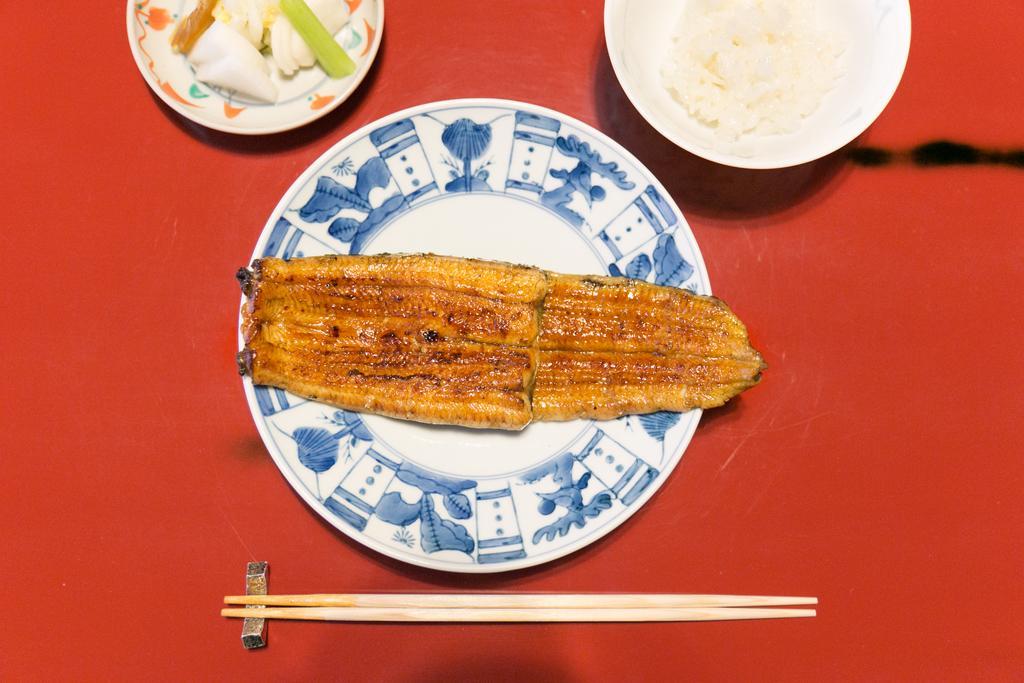How would you summarize this image in a sentence or two? In this picture, we see a plate containing food, chopsticks, a bowl containing rice and a plate containing eatables are placed on the red color table. 